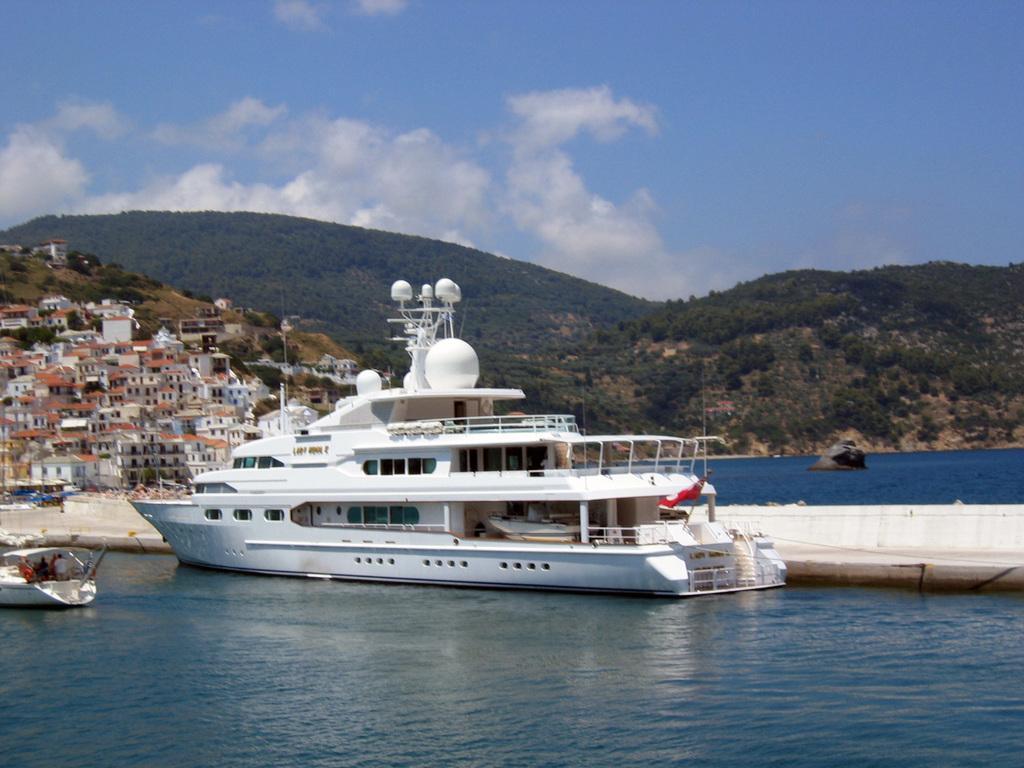Can you describe this image briefly? In this picture I can see the boats on the water. In the background I can see the trees, mountains and buildings. At the top I see the sky and clouds. On the right I can see the lake. 